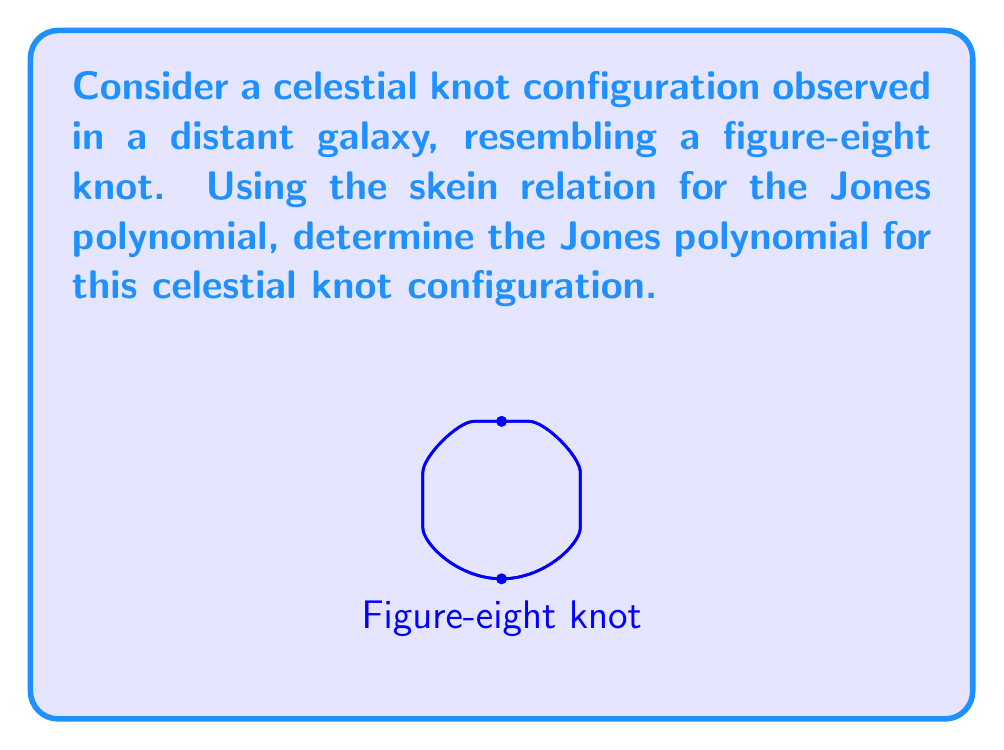Provide a solution to this math problem. To determine the Jones polynomial for the figure-eight knot, we'll use the skein relation and follow these steps:

1) The skein relation for the Jones polynomial is:
   $$t^{-1}V(L_+) - tV(L_-) = (t^{1/2} - t^{-1/2})V(L_0)$$
   where $L_+$, $L_-$, and $L_0$ are the positive crossing, negative crossing, and smoothed crossing respectively.

2) The figure-eight knot can be represented as a sum of simpler knots using the skein relation. We'll start by considering one of its crossings.

3) Let $V(4_1)$ be the Jones polynomial of the figure-eight knot. Applying the skein relation:
   $$t^{-1}V(4_1) - tV(\text{unknot}) = (t^{1/2} - t^{-1/2})V(\text{Hopf link})$$

4) We know that $V(\text{unknot}) = 1$ and $V(\text{Hopf link}) = -t^{1/2} - t^{-3/2}$

5) Substituting these values:
   $$t^{-1}V(4_1) - t = (t^{1/2} - t^{-1/2})(-t^{1/2} - t^{-3/2})$$

6) Simplifying the right side:
   $$t^{-1}V(4_1) - t = -t - t^{-1} + t^{-2} + 1$$

7) Multiplying both sides by $t$:
   $$V(4_1) = -t^2 - 1 + t + t^{-1}$$

8) Rearranging terms:
   $$V(4_1) = t^{-1} - 1 + t - t^2$$

This is the Jones polynomial for the figure-eight knot.
Answer: $V(4_1) = t^{-1} - 1 + t - t^2$ 